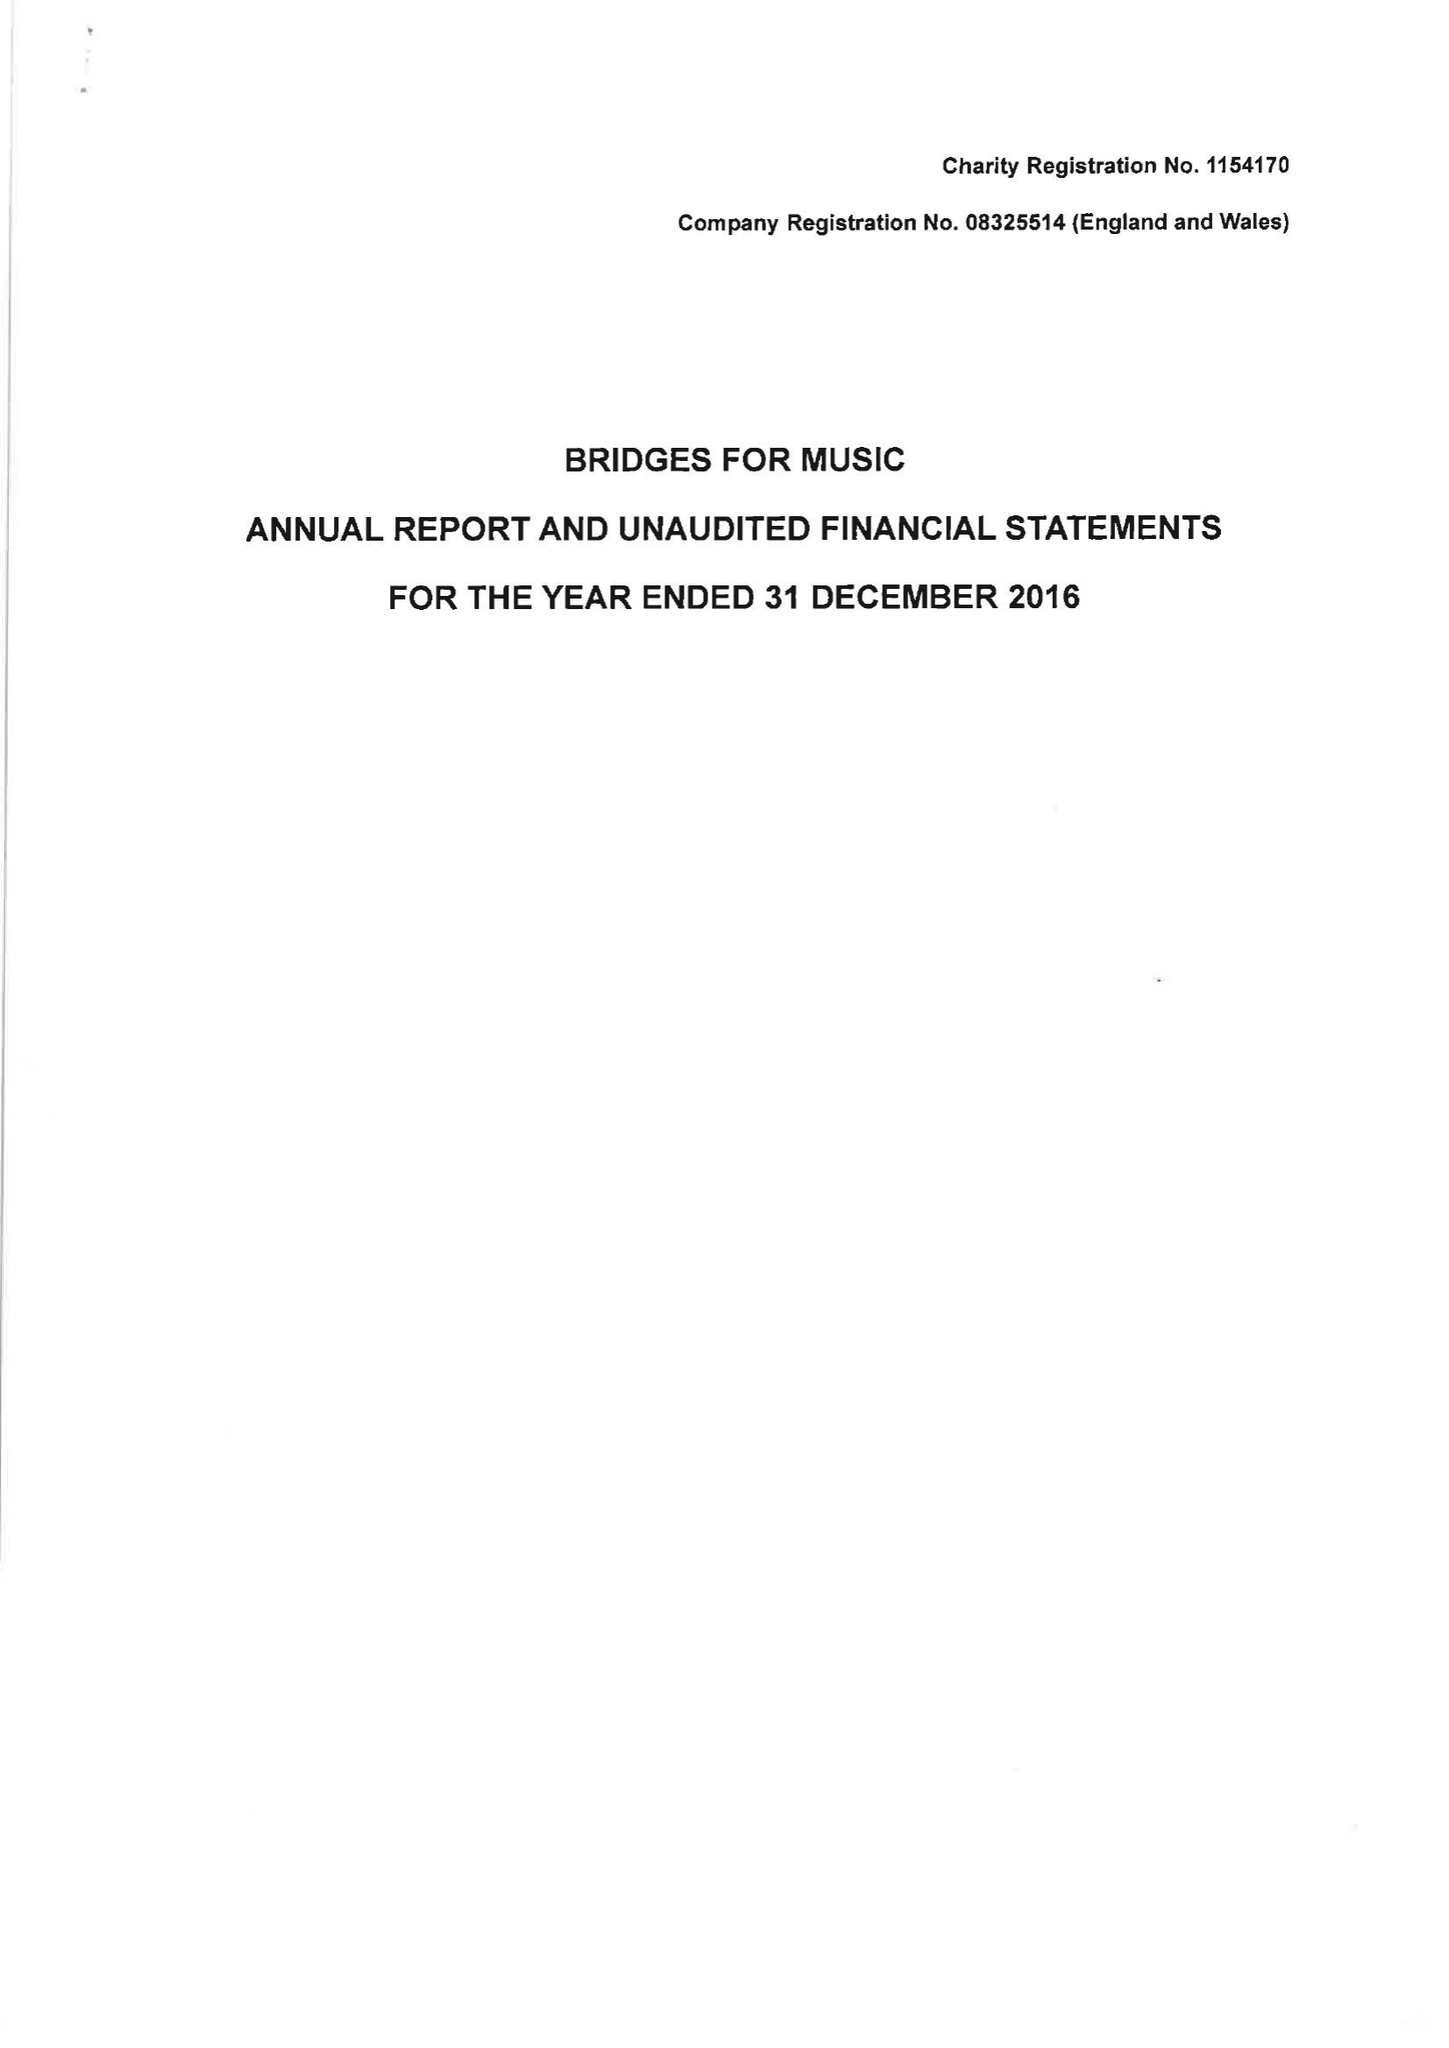What is the value for the address__post_town?
Answer the question using a single word or phrase. LONDON 